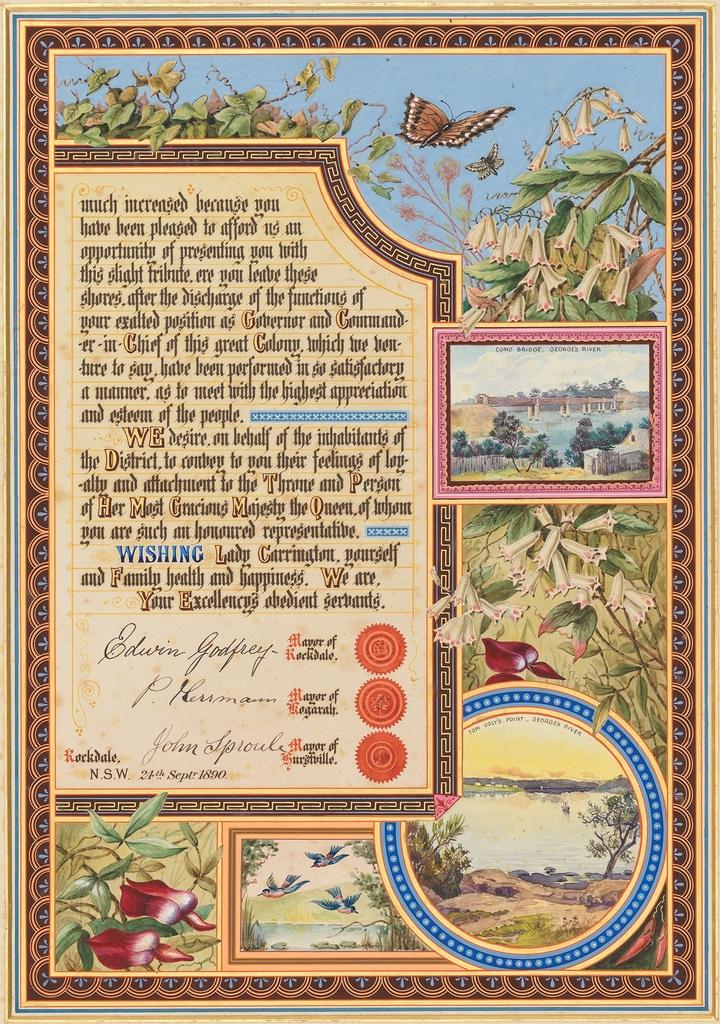What is the bold blue word on the page?
Offer a terse response. Wishing. What year is listed at the bottom of the text on this poster?
Offer a terse response. 1890. 